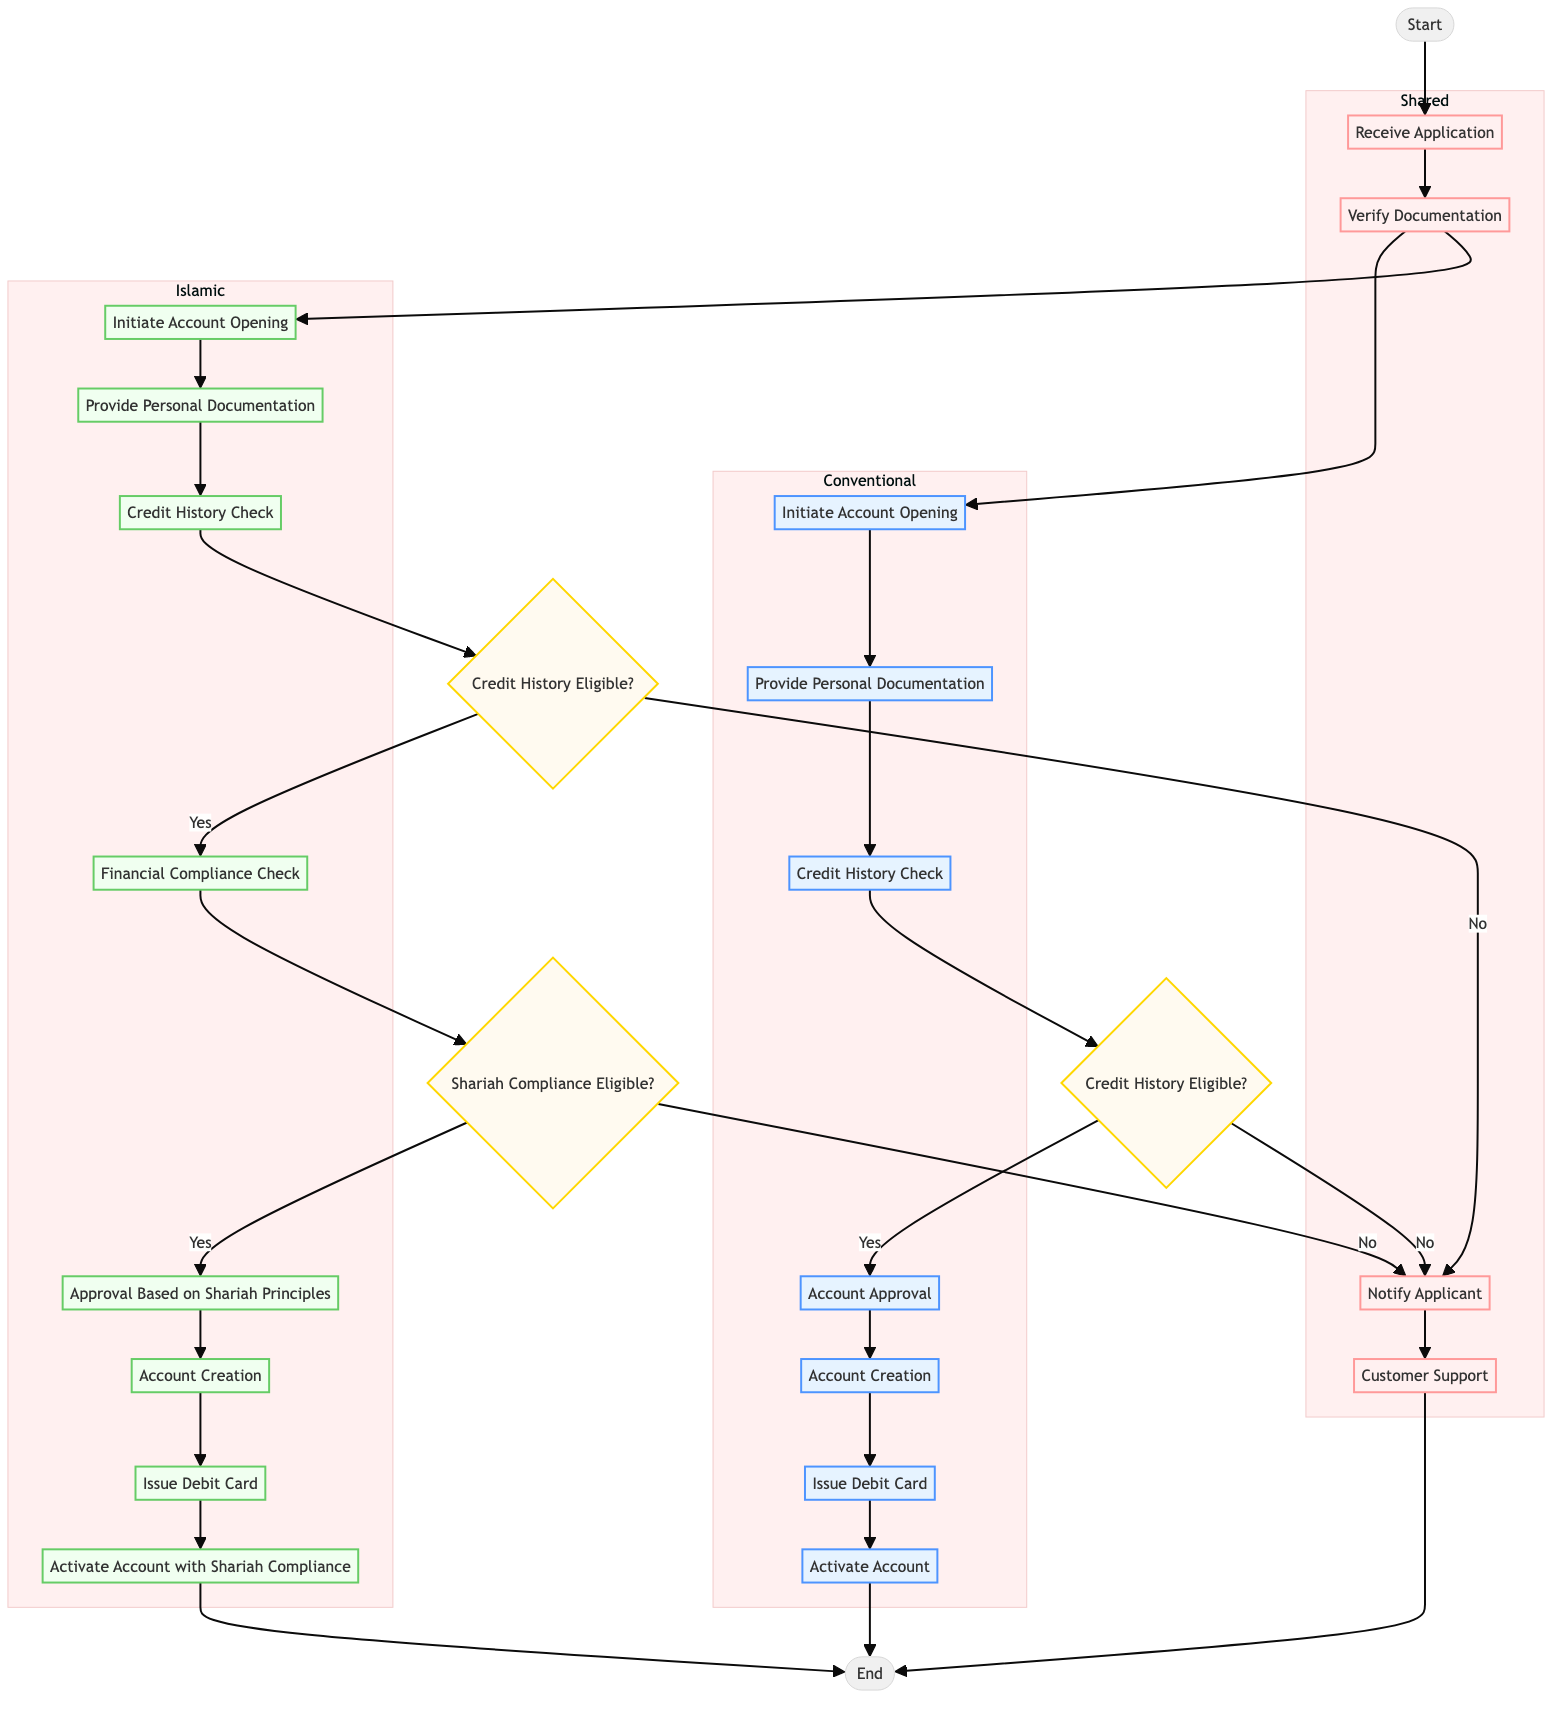What is the first activity in the conventional banking process? The first activity listed in the conventional banking process is "Initiate Account Opening (Conventional)," which follows the "Receive Application" step.
Answer: Initiate Account Opening (Conventional) What decision occurs after the credit history check in Islamic banking? After the credit history check in Islamic banking, the diagram shows a decision node labeled "Credit History Eligible?" that determines whether the process can continue based on the applicant's credit history.
Answer: Credit History Eligible? How many shared activities are there in the diagram? The diagram lists four shared activities: "Receive Application," "Verify Documentation," "Notify Applicant," and "Customer Support." Therefore, the total is four.
Answer: 4 What happens if the applicant is not credit history eligible in conventional banking? If the applicant is not credit history eligible in conventional banking, the workflow directs to "Notify Applicant," indicating that the applicant will be informed about the ineligibility.
Answer: Notify Applicant In Islamic banking, what is the step that comes directly after ensuring Shariah compliance eligibility? Following the decision on "Shariah Compliance Eligible?" in Islamic banking, if the applicant is eligible, the next step is "Approval Based on Shariah Principles."
Answer: Approval Based on Shariah Principles Which two classes of activities are included in the diagram? The diagram includes two classes of activities: "Conventional" activities and "Islamic" activities. Each class is visually distinct and follows its respective process flow.
Answer: Conventional and Islamic What is the final activity in both banking processes? In both the conventional and Islamic banking processes, the last activity directed is labeled "End," indicating the conclusion of the account opening processes.
Answer: End What is required after the "Provide Personal Documentation" step in both processes? After the "Provide Personal Documentation" step in both banking processes, a "Credit History Check" is required to assess the financial status of the applicant.
Answer: Credit History Check In conventional banking, what follows after account approval? After the "Account Approval" step in conventional banking, the workflow proceeds to "Account Creation," which signifies the establishment of the banking account.
Answer: Account Creation 